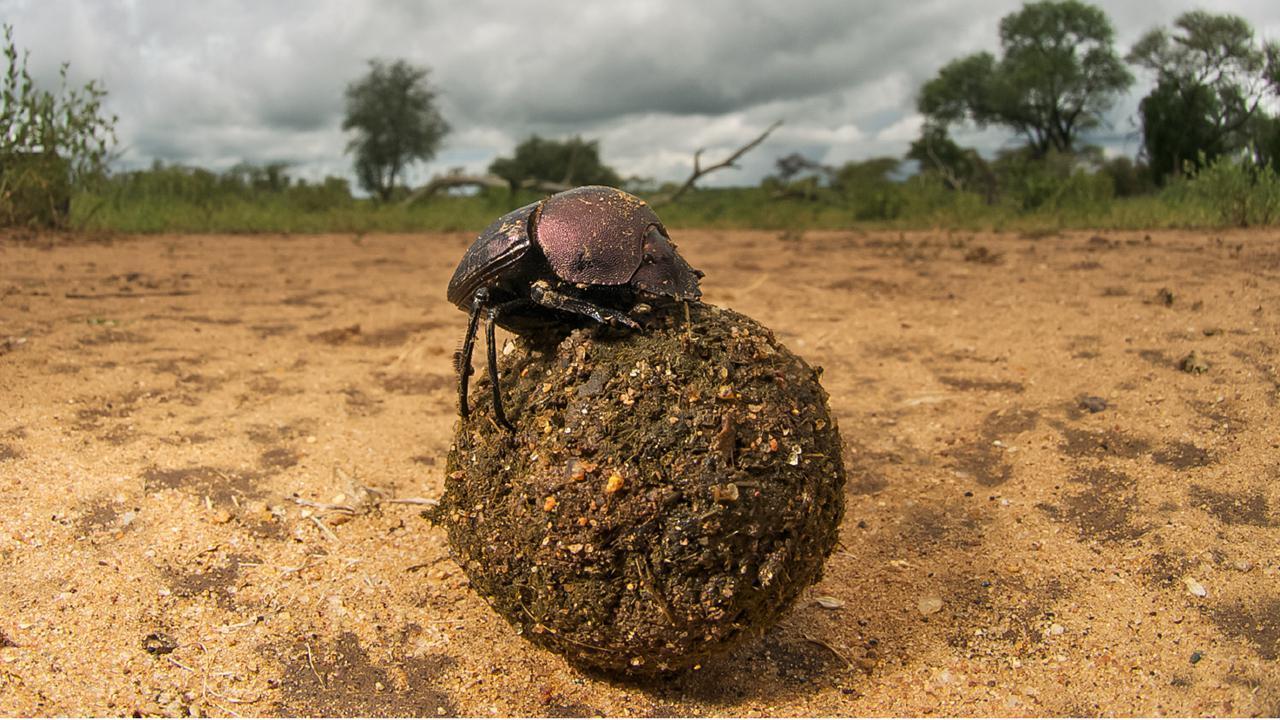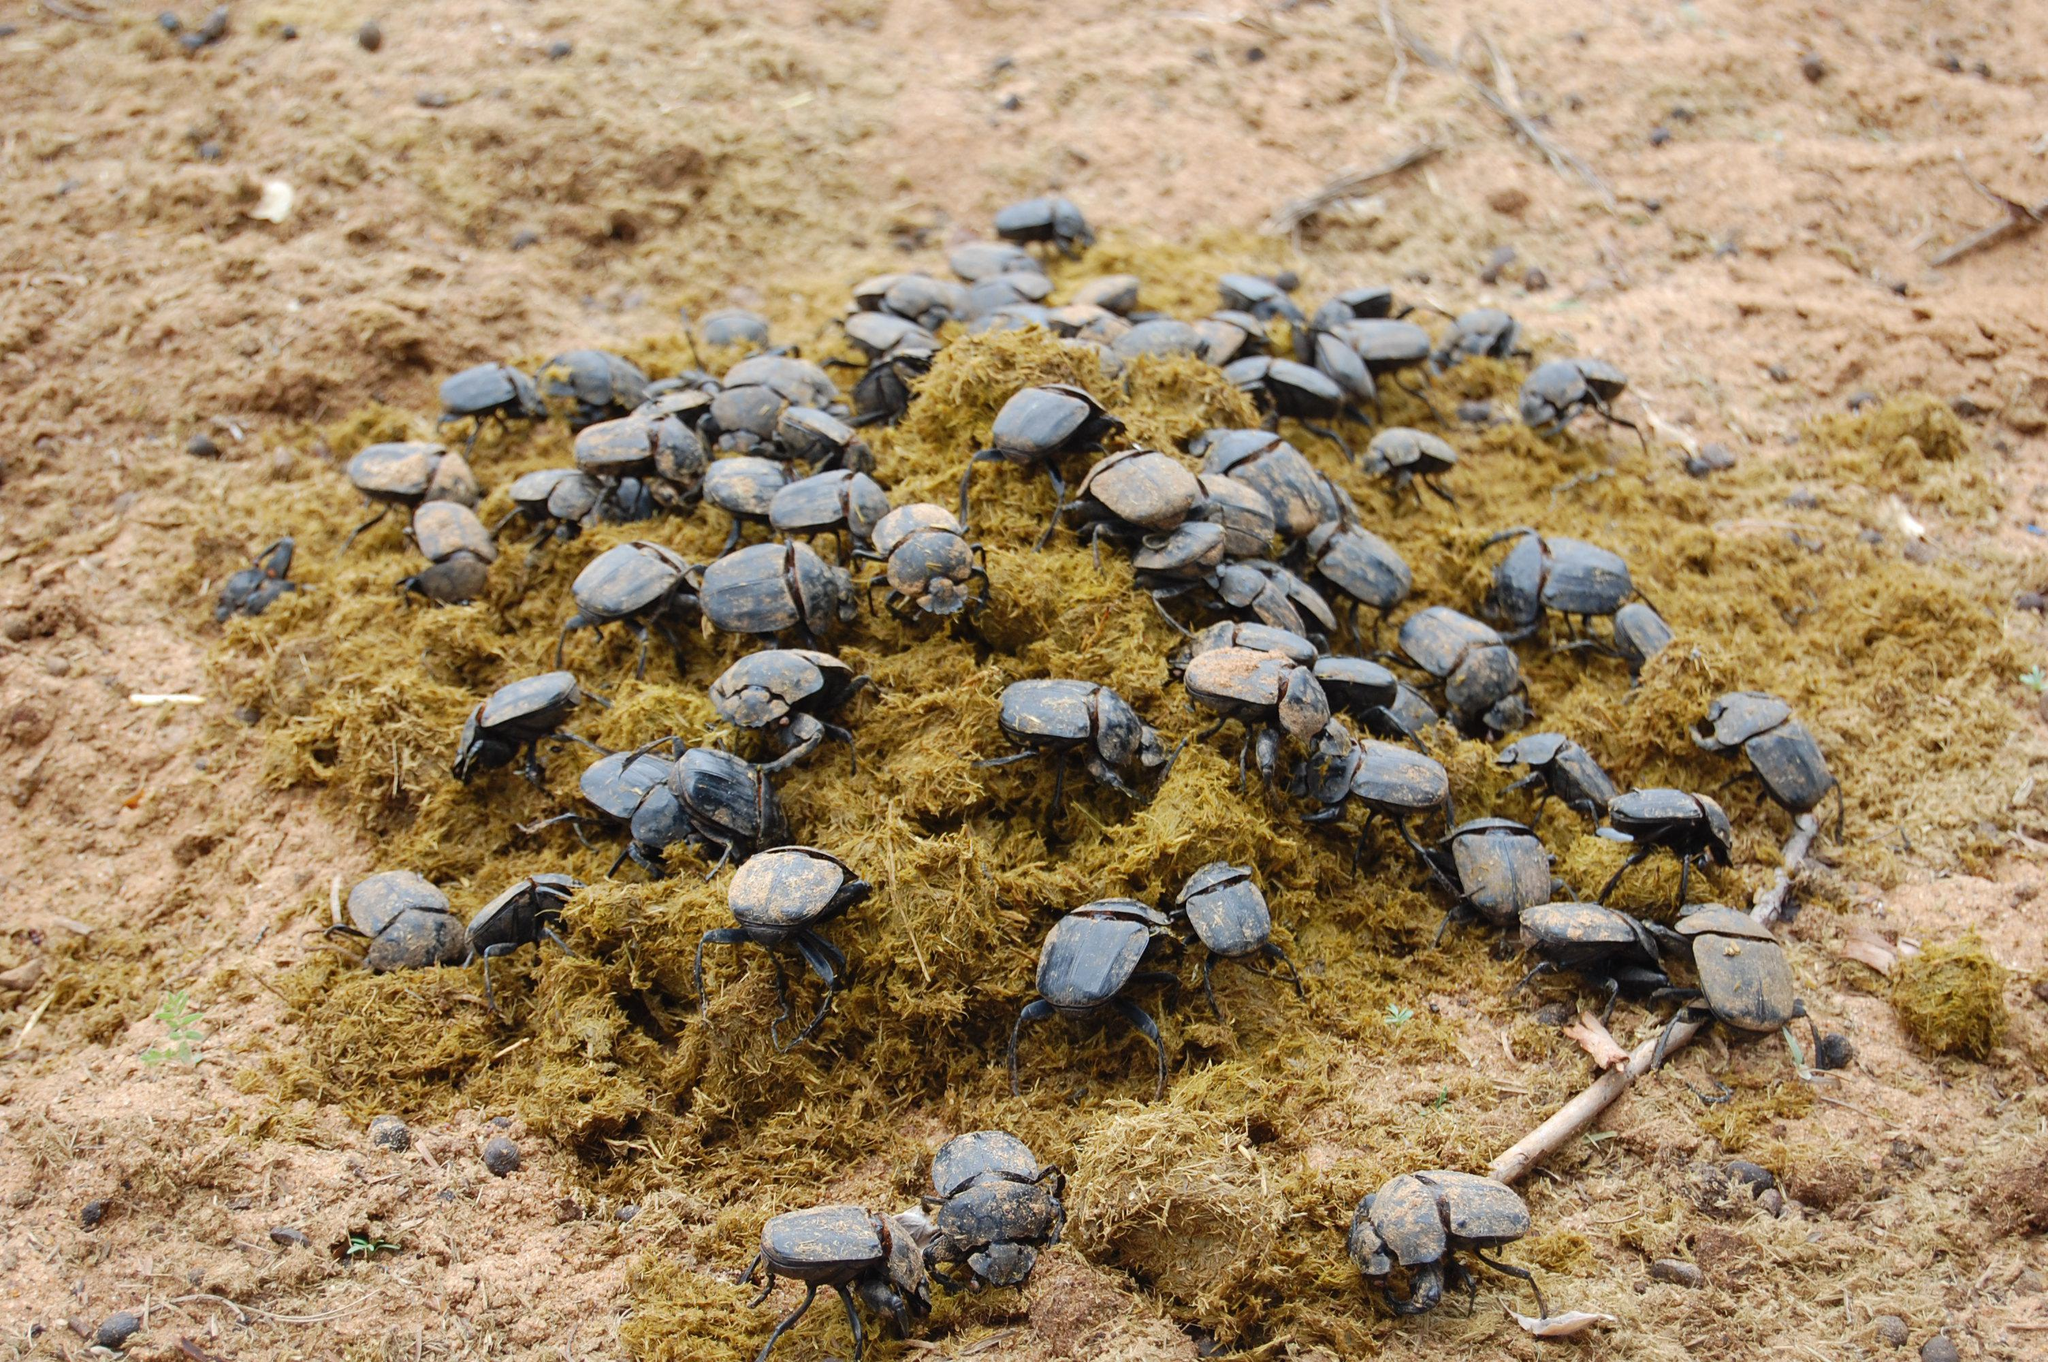The first image is the image on the left, the second image is the image on the right. Analyze the images presented: Is the assertion "The right image has a beetle crawling on a persons hand." valid? Answer yes or no. No. The first image is the image on the left, the second image is the image on the right. Assess this claim about the two images: "A beetle crawls on a persons hand in the image on the right.". Correct or not? Answer yes or no. No. 